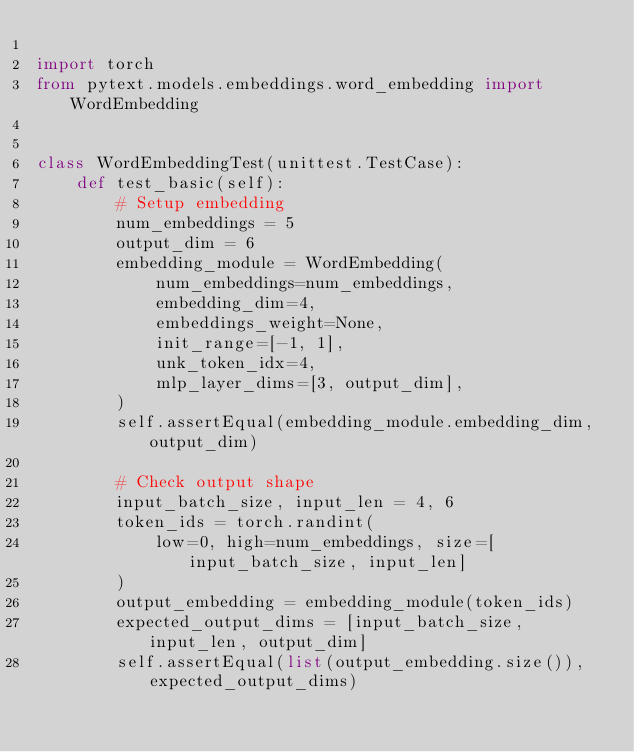Convert code to text. <code><loc_0><loc_0><loc_500><loc_500><_Python_>
import torch
from pytext.models.embeddings.word_embedding import WordEmbedding


class WordEmbeddingTest(unittest.TestCase):
    def test_basic(self):
        # Setup embedding
        num_embeddings = 5
        output_dim = 6
        embedding_module = WordEmbedding(
            num_embeddings=num_embeddings,
            embedding_dim=4,
            embeddings_weight=None,
            init_range=[-1, 1],
            unk_token_idx=4,
            mlp_layer_dims=[3, output_dim],
        )
        self.assertEqual(embedding_module.embedding_dim, output_dim)

        # Check output shape
        input_batch_size, input_len = 4, 6
        token_ids = torch.randint(
            low=0, high=num_embeddings, size=[input_batch_size, input_len]
        )
        output_embedding = embedding_module(token_ids)
        expected_output_dims = [input_batch_size, input_len, output_dim]
        self.assertEqual(list(output_embedding.size()), expected_output_dims)
</code> 